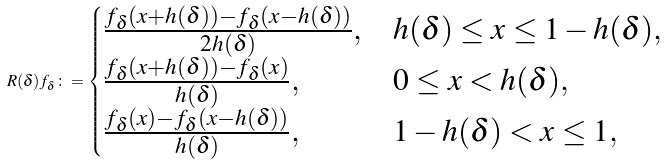Convert formula to latex. <formula><loc_0><loc_0><loc_500><loc_500>R ( \delta ) f _ { \delta } \colon = \begin{cases} \frac { f _ { \delta } ( x + h ( \delta ) ) - f _ { \delta } ( x - h ( \delta ) ) } { 2 h ( \delta ) } , & h ( \delta ) \leq x \leq 1 - h ( \delta ) , \\ \frac { f _ { \delta } ( x + h ( \delta ) ) - f _ { \delta } ( x ) } { h ( \delta ) } , & 0 \leq x < h ( \delta ) , \\ \frac { f _ { \delta } ( x ) - f _ { \delta } ( x - h ( \delta ) ) } { h ( \delta ) } , & 1 - h ( \delta ) < x \leq 1 , \end{cases}</formula> 